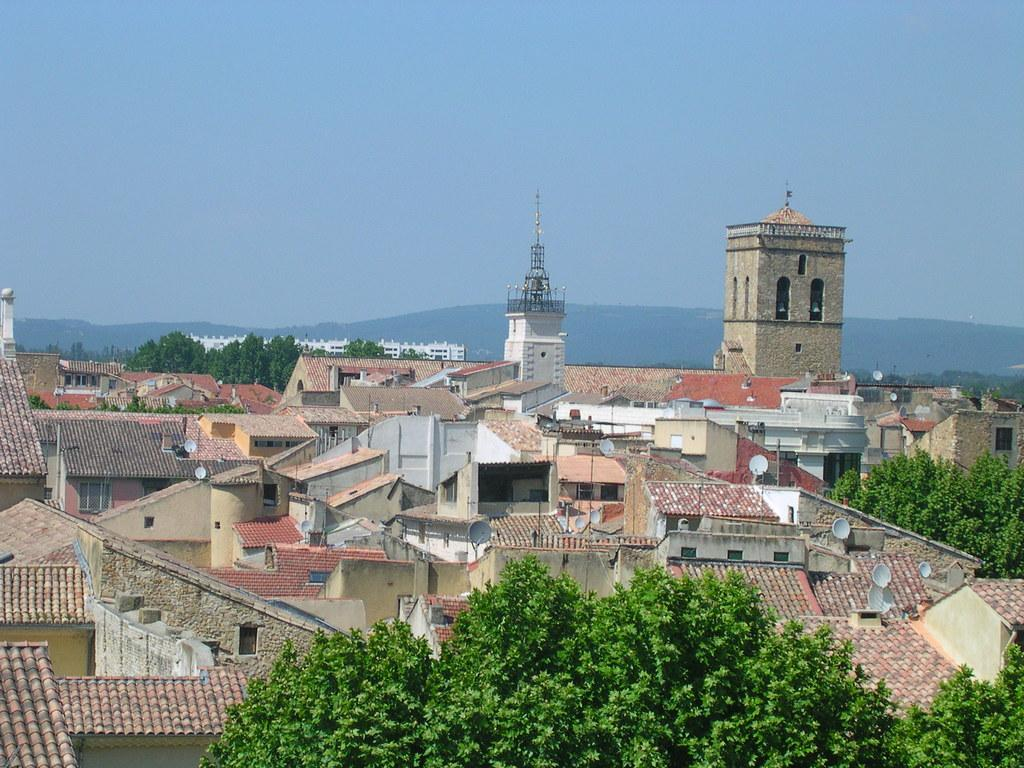What type of vegetation can be seen in the image? There are trees in the image. What type of structures are present in the image? There are houses and a tower in the image. What objects are attached to the houses in the image? There are satellite dishes in the image. What geographical feature is visible in the background of the image? There is a hill in the background of the image. What is visible in the sky in the image? The sky is visible in the background of the image. What type of quiver is hanging on the tower in the image? There is no quiver present in the image; the tower does not have any visible quiver. Can you describe the ship that is sailing in the background of the image? There is no ship present in the image; the background only shows a hill and the sky. 